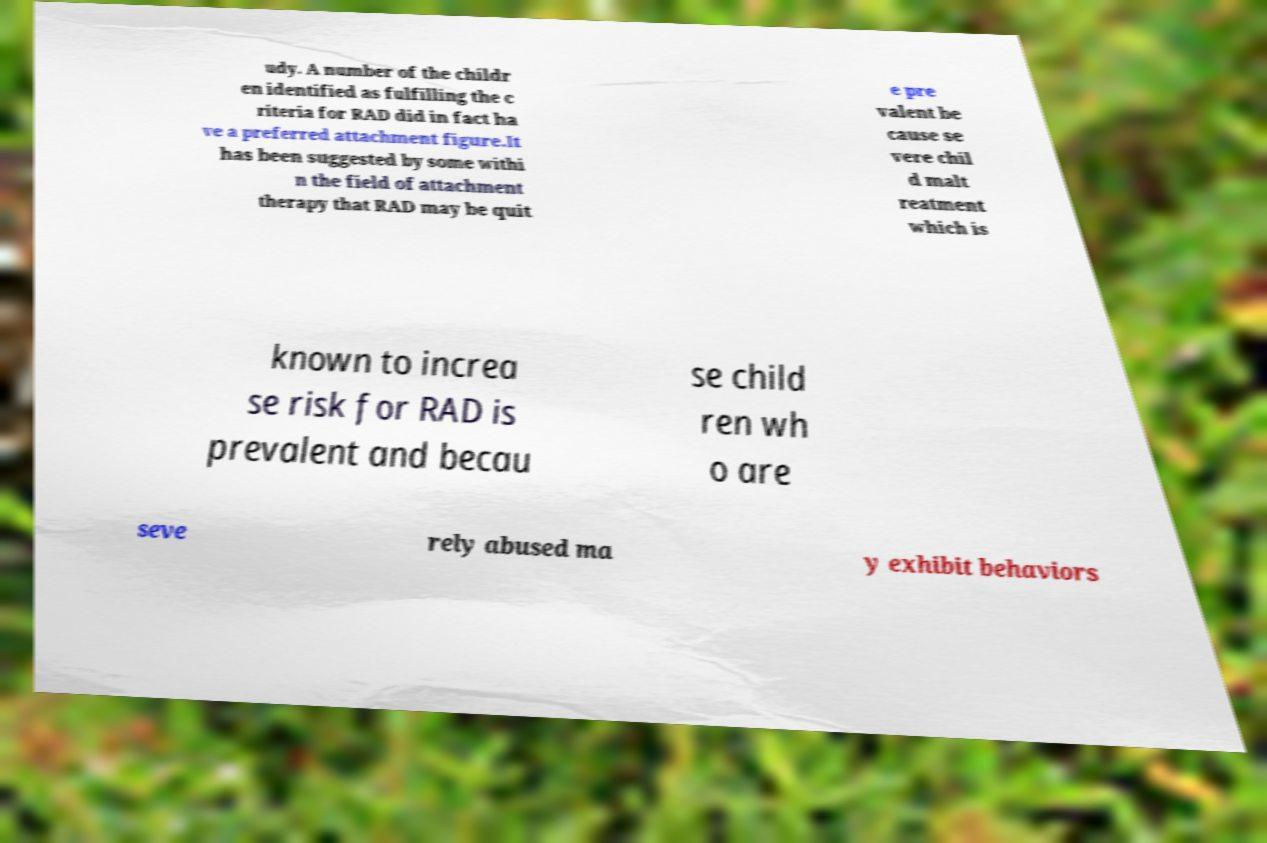Please identify and transcribe the text found in this image. udy. A number of the childr en identified as fulfilling the c riteria for RAD did in fact ha ve a preferred attachment figure.It has been suggested by some withi n the field of attachment therapy that RAD may be quit e pre valent be cause se vere chil d malt reatment which is known to increa se risk for RAD is prevalent and becau se child ren wh o are seve rely abused ma y exhibit behaviors 